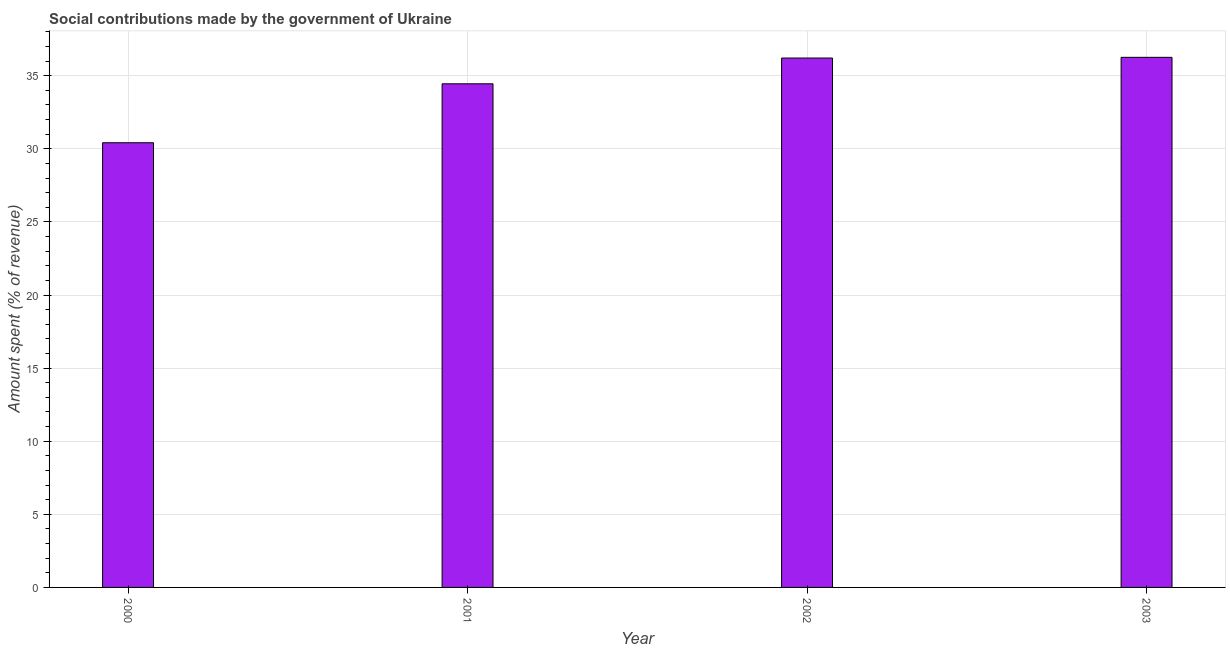What is the title of the graph?
Your response must be concise. Social contributions made by the government of Ukraine. What is the label or title of the X-axis?
Offer a terse response. Year. What is the label or title of the Y-axis?
Offer a terse response. Amount spent (% of revenue). What is the amount spent in making social contributions in 2001?
Keep it short and to the point. 34.45. Across all years, what is the maximum amount spent in making social contributions?
Give a very brief answer. 36.26. Across all years, what is the minimum amount spent in making social contributions?
Make the answer very short. 30.41. In which year was the amount spent in making social contributions maximum?
Provide a succinct answer. 2003. In which year was the amount spent in making social contributions minimum?
Your response must be concise. 2000. What is the sum of the amount spent in making social contributions?
Keep it short and to the point. 137.33. What is the difference between the amount spent in making social contributions in 2002 and 2003?
Keep it short and to the point. -0.05. What is the average amount spent in making social contributions per year?
Ensure brevity in your answer.  34.33. What is the median amount spent in making social contributions?
Your response must be concise. 35.33. Is the amount spent in making social contributions in 2000 less than that in 2003?
Give a very brief answer. Yes. What is the difference between the highest and the second highest amount spent in making social contributions?
Provide a short and direct response. 0.05. What is the difference between the highest and the lowest amount spent in making social contributions?
Keep it short and to the point. 5.84. In how many years, is the amount spent in making social contributions greater than the average amount spent in making social contributions taken over all years?
Make the answer very short. 3. Are all the bars in the graph horizontal?
Offer a terse response. No. How many years are there in the graph?
Provide a succinct answer. 4. What is the difference between two consecutive major ticks on the Y-axis?
Give a very brief answer. 5. What is the Amount spent (% of revenue) of 2000?
Offer a very short reply. 30.41. What is the Amount spent (% of revenue) of 2001?
Make the answer very short. 34.45. What is the Amount spent (% of revenue) in 2002?
Make the answer very short. 36.21. What is the Amount spent (% of revenue) of 2003?
Your response must be concise. 36.26. What is the difference between the Amount spent (% of revenue) in 2000 and 2001?
Provide a succinct answer. -4.03. What is the difference between the Amount spent (% of revenue) in 2000 and 2002?
Provide a short and direct response. -5.79. What is the difference between the Amount spent (% of revenue) in 2000 and 2003?
Offer a terse response. -5.84. What is the difference between the Amount spent (% of revenue) in 2001 and 2002?
Provide a succinct answer. -1.76. What is the difference between the Amount spent (% of revenue) in 2001 and 2003?
Your response must be concise. -1.81. What is the difference between the Amount spent (% of revenue) in 2002 and 2003?
Offer a very short reply. -0.05. What is the ratio of the Amount spent (% of revenue) in 2000 to that in 2001?
Provide a short and direct response. 0.88. What is the ratio of the Amount spent (% of revenue) in 2000 to that in 2002?
Offer a terse response. 0.84. What is the ratio of the Amount spent (% of revenue) in 2000 to that in 2003?
Make the answer very short. 0.84. What is the ratio of the Amount spent (% of revenue) in 2001 to that in 2002?
Offer a terse response. 0.95. What is the ratio of the Amount spent (% of revenue) in 2001 to that in 2003?
Give a very brief answer. 0.95. 